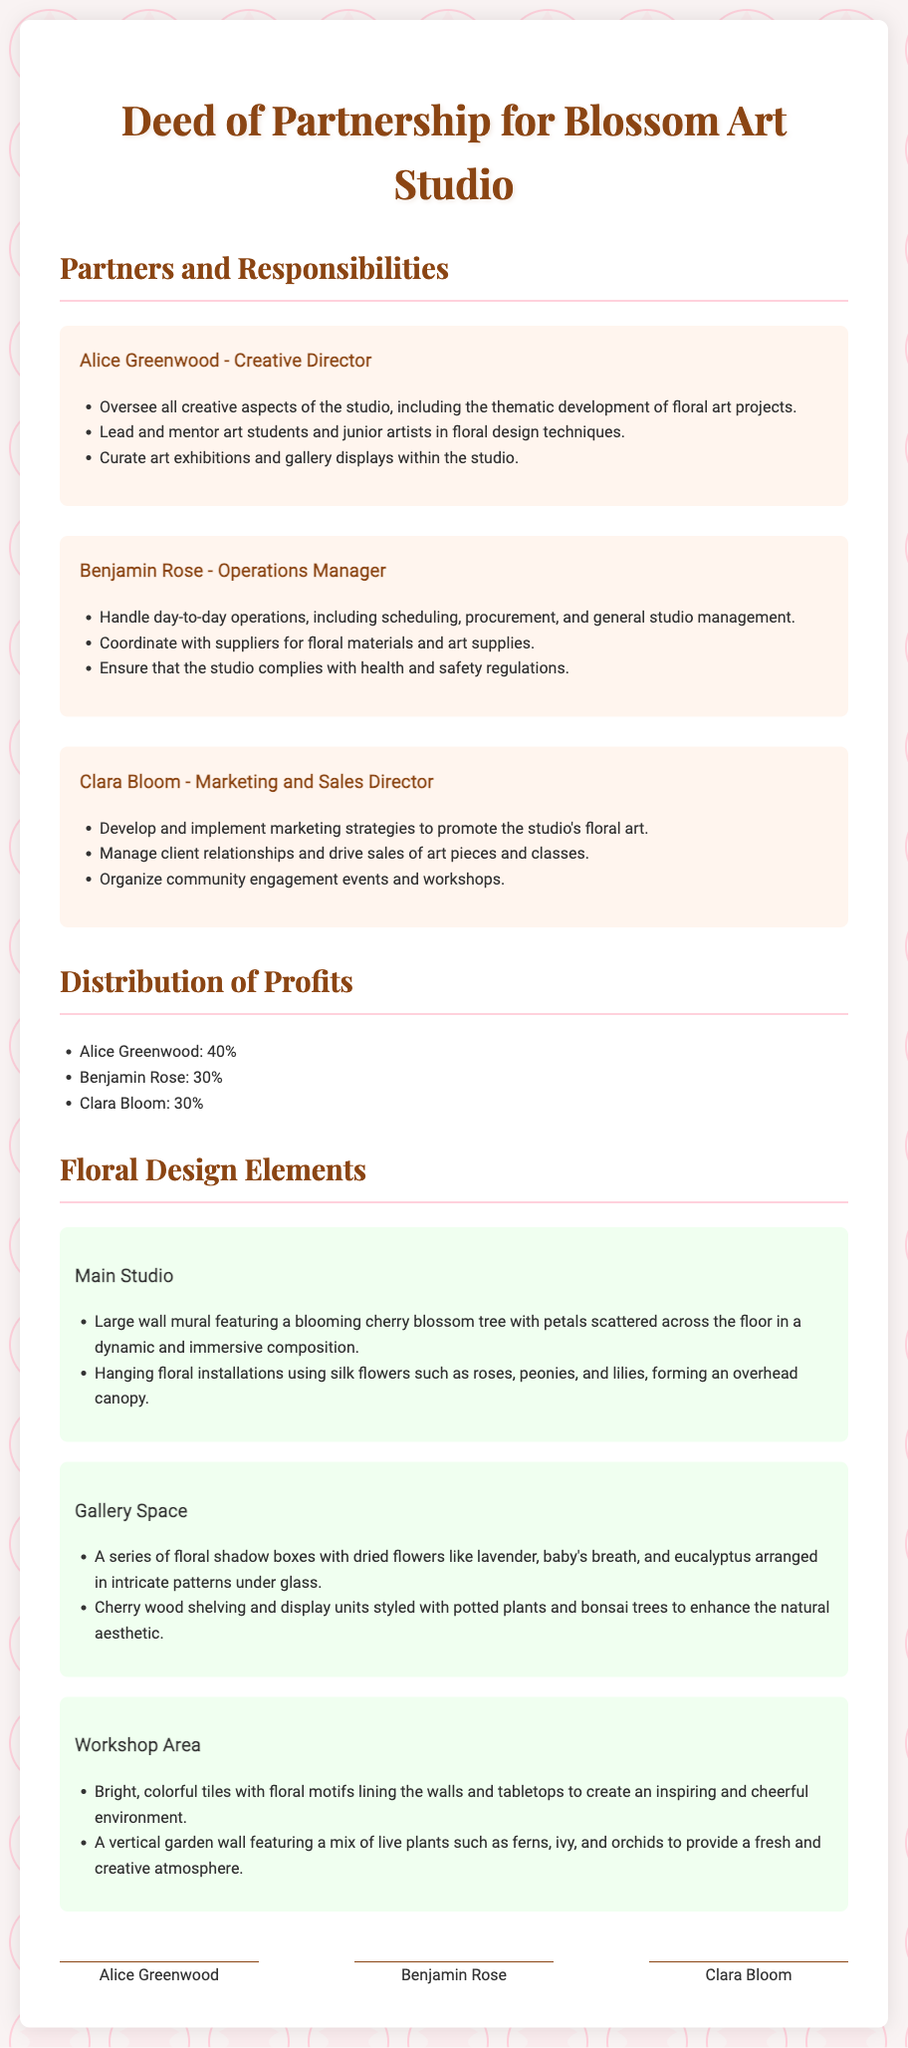What is the name of the flower-themed art studio? The name of the studio is clearly mentioned in the title of the document.
Answer: Blossom Art Studio Who is the Creative Director? The document lists Alice Greenwood as the Creative Director under the Partners and Responsibilities section.
Answer: Alice Greenwood What percentage of profits does Benjamin Rose receive? The profit distribution section specifies the percentages allocated to each partner, including Benjamin Rose.
Answer: 30% What is one installation in the Main Studio? The Main Studio floral design section describes specific floral elements used in that area, including one installation.
Answer: Hanging floral installations What type of flowers are featured in the Gallery Space shadow boxes? The document provides details on the types of dried flowers arranged in the shadow boxes within the Gallery Space.
Answer: Lavender, baby's breath, and eucalyptus Who is responsible for marketing and sales? Clara Bloom's role and responsibilities in the document identify her as the person in charge of marketing and sales.
Answer: Clara Bloom How many partners are there in the partnership? The document lists three partners in the Partners and Responsibilities section.
Answer: Three What is one element featured in the Workshop Area? The Workshop Area description includes specific floral elements that contribute to its design.
Answer: Vertical garden wall What theme is primarily associated with the floral art projects? The document highlights the specific theme articulated by Alice Greenwood in her role description.
Answer: Floral art 